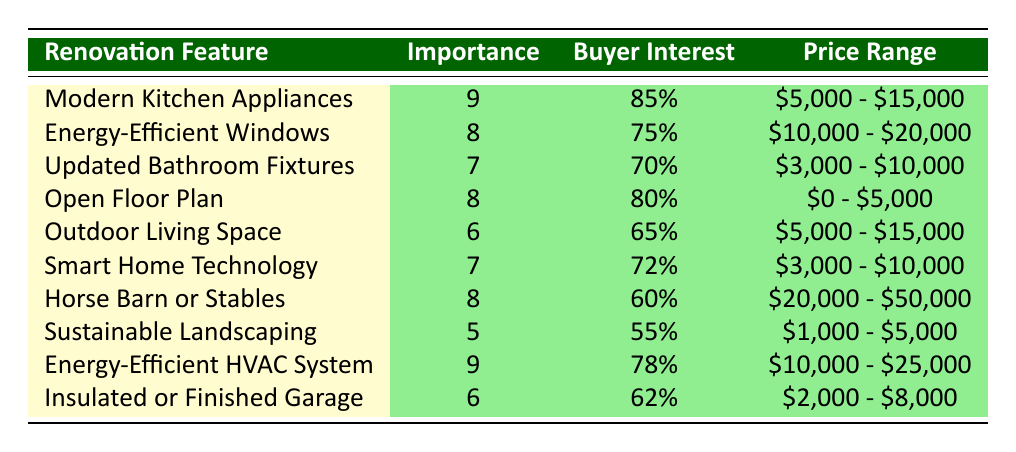What is the highest importance level among the renovation features? The data shows that the highest importance level is 9, which is noted for both "Modern Kitchen Appliances" and "Energy-Efficient HVAC System."
Answer: 9 Which renovation feature has the highest buyer interest percentage? Upon reviewing the table, "Modern Kitchen Appliances" has the highest buyer interest percentage at 85%.
Answer: 85% What is the price range for "Energy-Efficient Windows"? The table indicates that the price range for "Energy-Efficient Windows" is $10,000 - $20,000.
Answer: $10,000 - $20,000 What is the average importance level of all renovation features? Adding the importance levels (9 + 8 + 7 + 8 + 6 + 7 + 8 + 5 + 9 + 6) gives a total of 70. There are 10 features, so the average is 70/10 = 7.
Answer: 7 Do more than 70% of buyers show interest in "Energy-Efficient HVAC System"? According to the table, "Energy-Efficient HVAC System" has a buyer interest percentage of 78%, which is indeed more than 70%.
Answer: Yes Is there a renovation feature with a buyer interest percentage lower than 60%? In the table, "Horse Barn or Stables" has a buyer interest percentage of 60%, while "Sustainable Landscaping" has a lower interest at 55%.
Answer: Yes Which features have an importance level of 8? The features with an importance level of 8 are "Energy-Efficient Windows," "Open Floor Plan," and "Horse Barn or Stables."
Answer: 3 features Calculate the total price range for the two highest importance level features. The two highest importance level features are "Modern Kitchen Appliances" ($5,000 - $15,000) and "Energy-Efficient HVAC System" ($10,000 - $25,000). The total price range is not straightforward, but we can assume it overlaps. Hence the total spans from $5,000 (minimum from first) to $25,000 (maximum from second).
Answer: $5,000 - $25,000 What percentage of buyers are interested in "Smart Home Technology"? The table shows that 72% of buyers are interested in "Smart Home Technology."
Answer: 72% Which feature has the lowest buyer interest percentage? The lowest buyer interest percentage is for "Sustainable Landscaping," which is at 55%.
Answer: 55% 